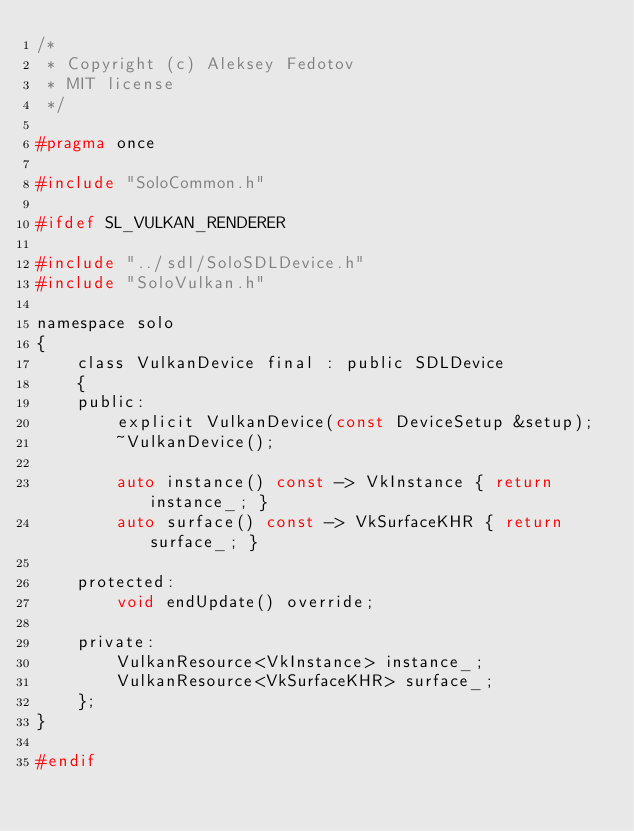Convert code to text. <code><loc_0><loc_0><loc_500><loc_500><_C_>/* 
 * Copyright (c) Aleksey Fedotov 
 * MIT license 
 */

#pragma once

#include "SoloCommon.h"

#ifdef SL_VULKAN_RENDERER

#include "../sdl/SoloSDLDevice.h"
#include "SoloVulkan.h"

namespace solo
{
    class VulkanDevice final : public SDLDevice
    {
    public:
        explicit VulkanDevice(const DeviceSetup &setup);
        ~VulkanDevice();

        auto instance() const -> VkInstance { return instance_; }
        auto surface() const -> VkSurfaceKHR { return surface_; }

    protected:
        void endUpdate() override;

    private:
        VulkanResource<VkInstance> instance_;
        VulkanResource<VkSurfaceKHR> surface_;
    };
}

#endif
</code> 